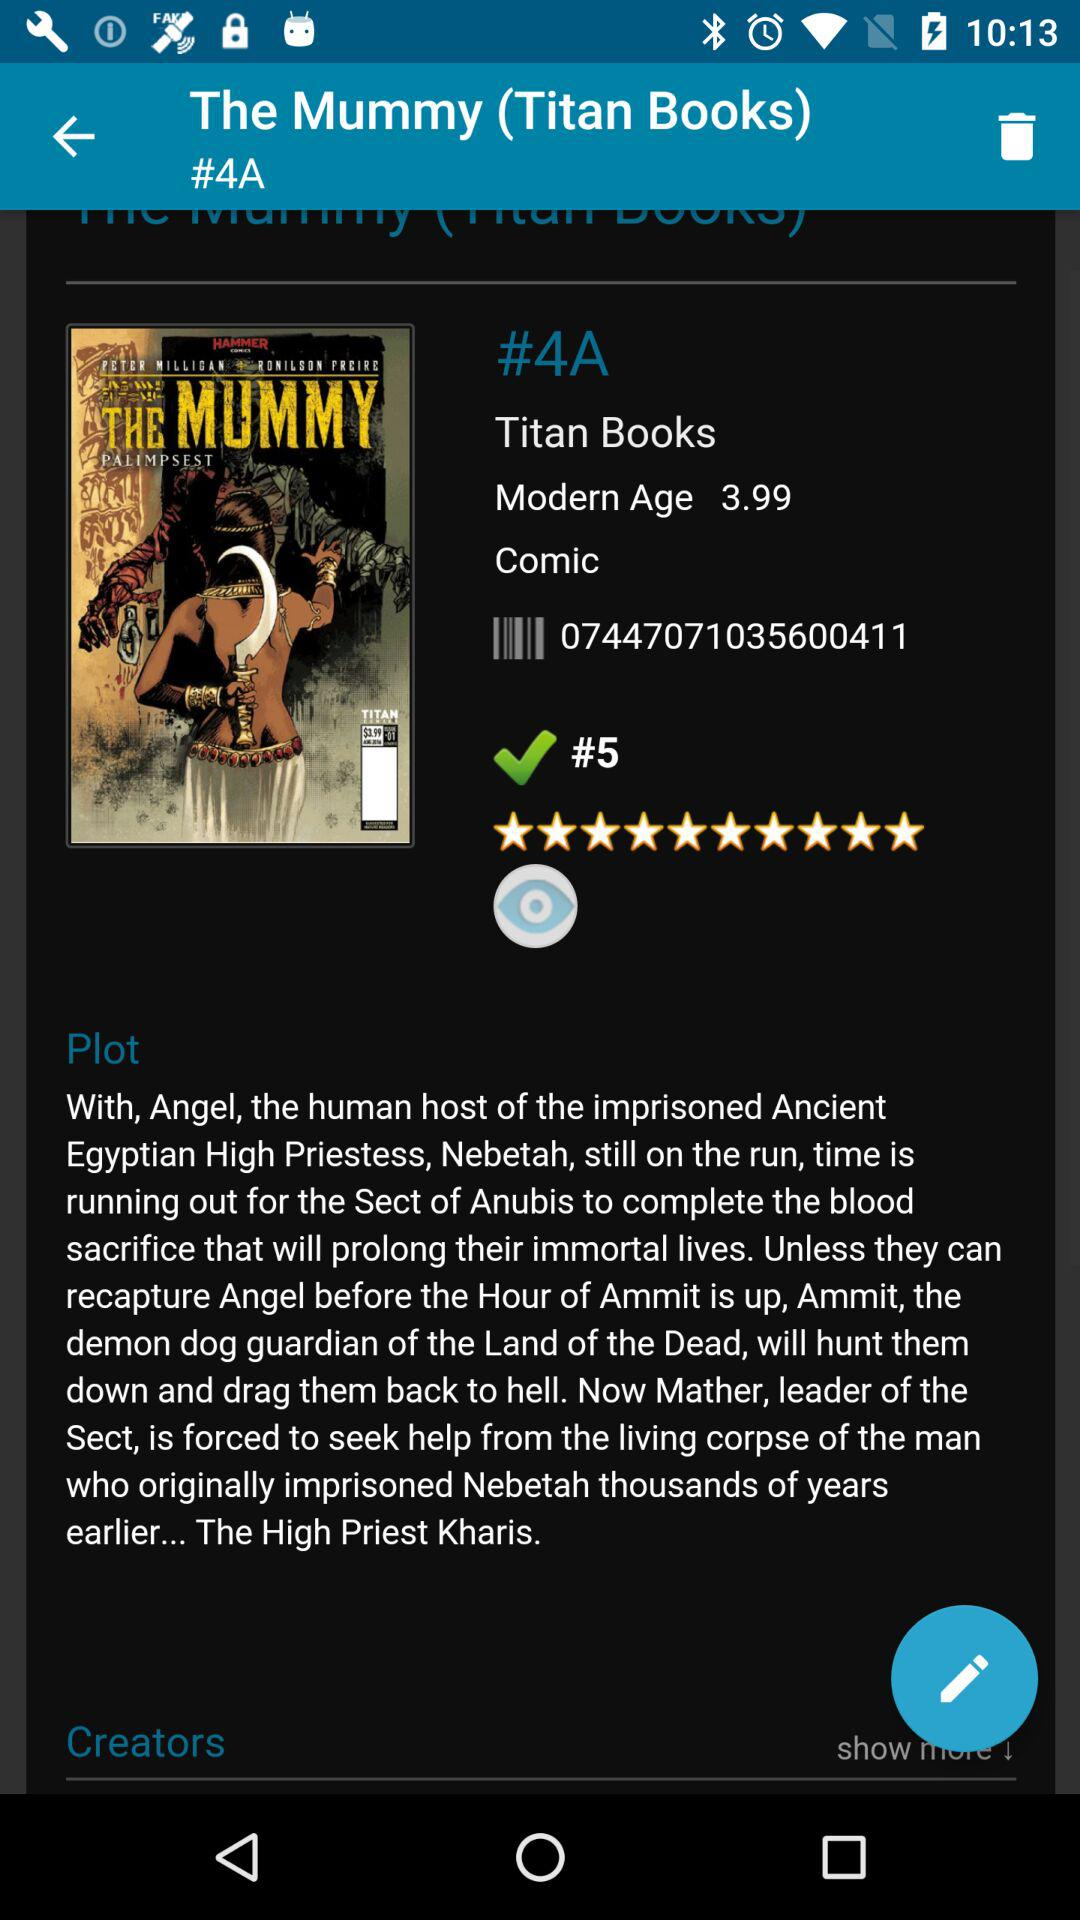What is the rating? The rating is 10 stars. 